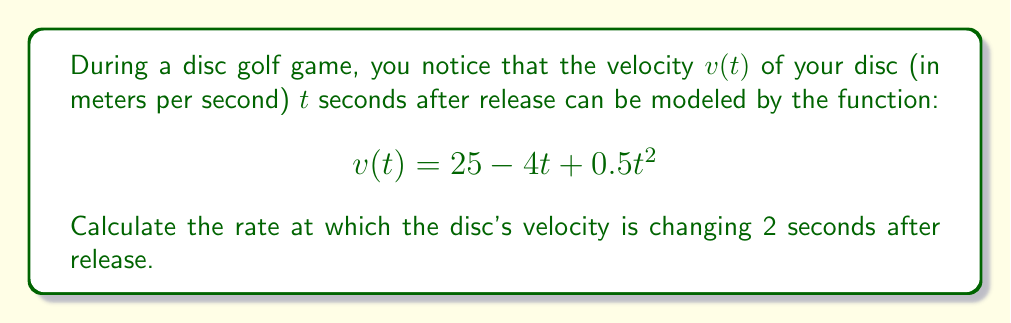What is the answer to this math problem? To solve this problem, we need to follow these steps:

1) The rate at which the disc's velocity is changing is given by the derivative of the velocity function with respect to time.

2) Let's start by finding the derivative of $v(t)$:

   $$v(t) = 25 - 4t + 0.5t^2$$
   
   $$\frac{d}{dt}[v(t)] = \frac{d}{dt}[25] - \frac{d}{dt}[4t] + \frac{d}{dt}[0.5t^2]$$
   
   $$v'(t) = 0 - 4 + 0.5 \cdot 2t$$
   
   $$v'(t) = -4 + t$$

3) The question asks for the rate of change 2 seconds after release. So we need to evaluate $v'(t)$ at $t = 2$:

   $$v'(2) = -4 + 2 = -2$$

4) Interpret the result: The negative value indicates that the velocity is decreasing at this point in time. The magnitude of 2 means that the velocity is decreasing at a rate of 2 meters per second, per second.
Answer: The rate at which the disc's velocity is changing 2 seconds after release is $-2$ m/s². 